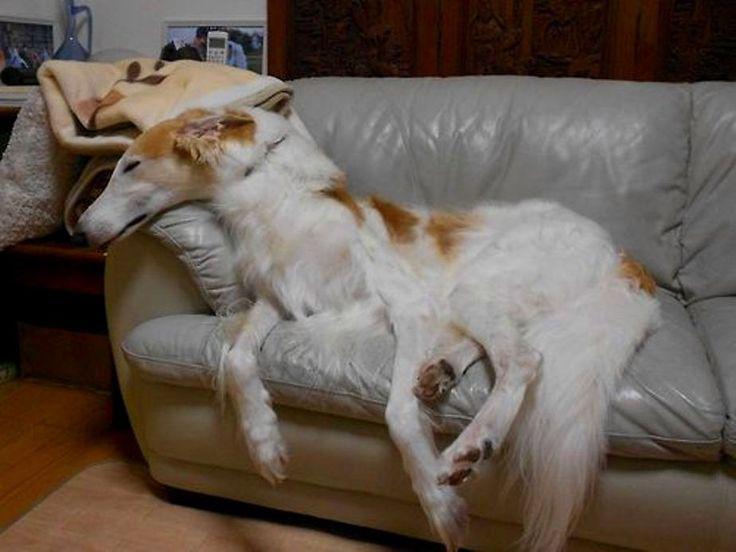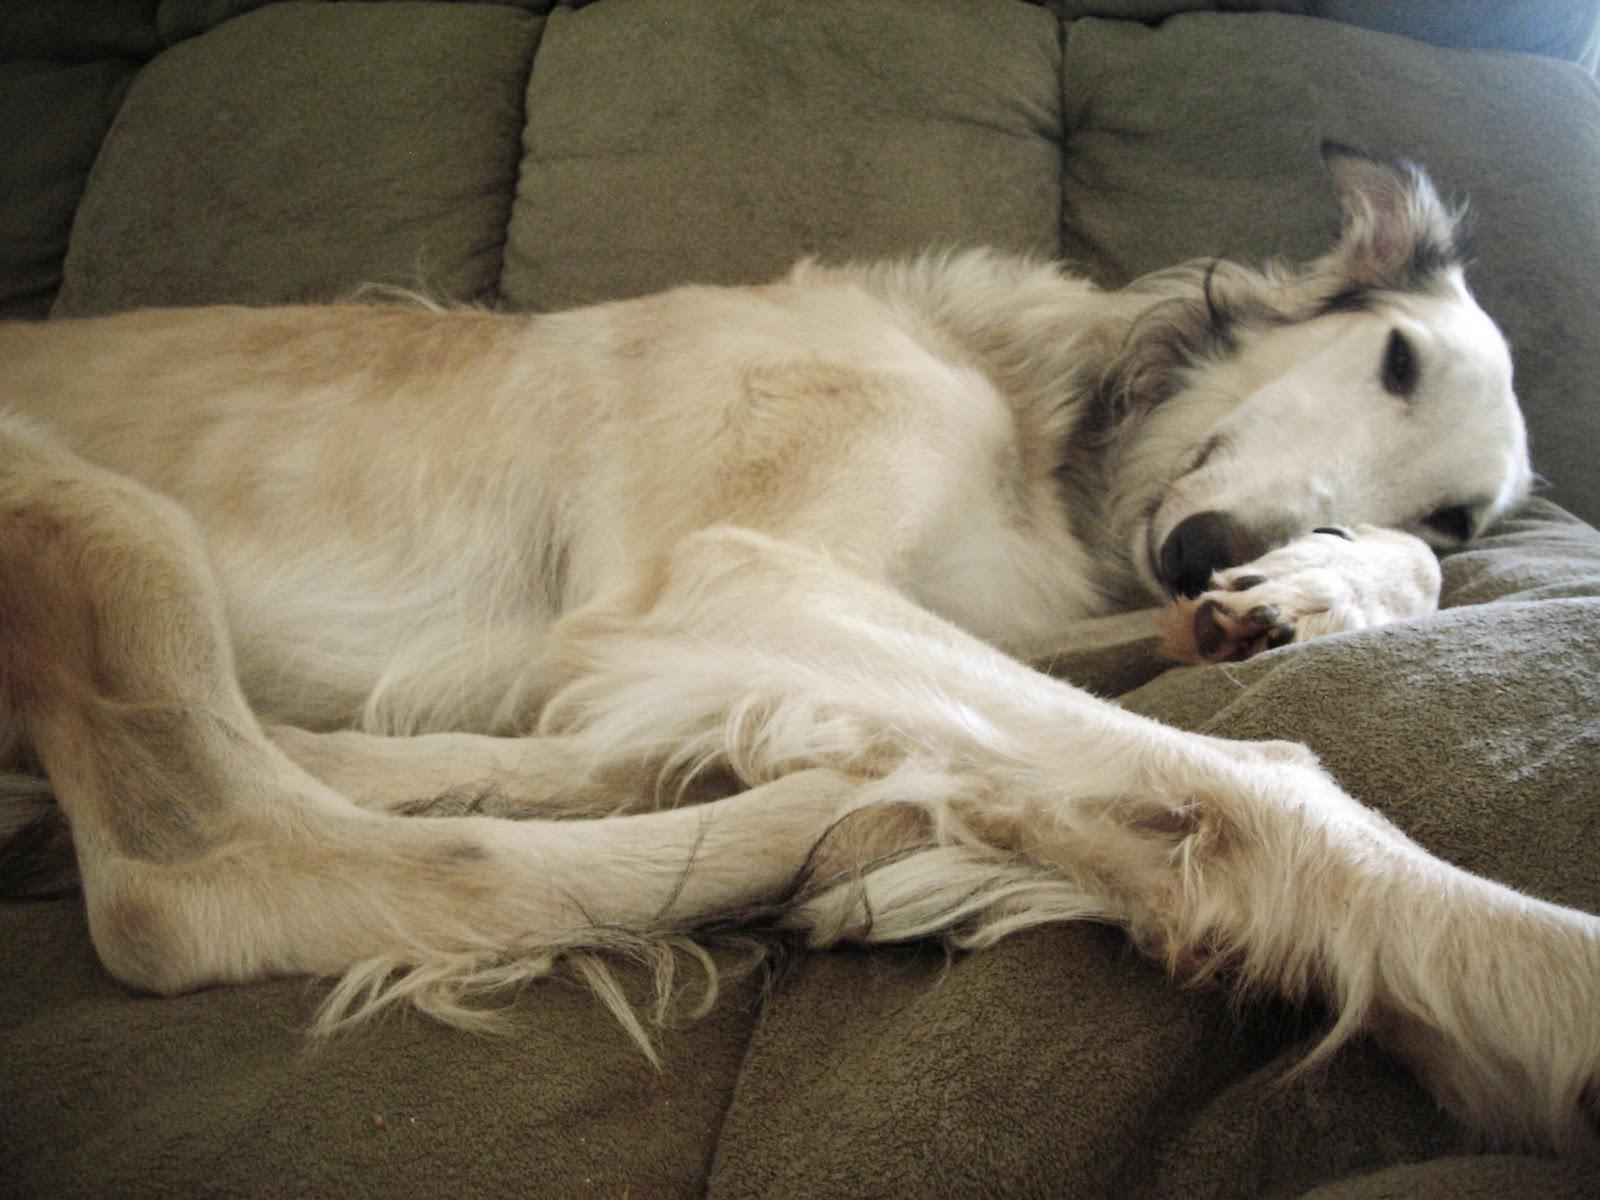The first image is the image on the left, the second image is the image on the right. Given the left and right images, does the statement "The right image contains at least two dogs laying down on a couch." hold true? Answer yes or no. No. The first image is the image on the left, the second image is the image on the right. Given the left and right images, does the statement "There are two dogs lying on the couch in the image on the right." hold true? Answer yes or no. No. 